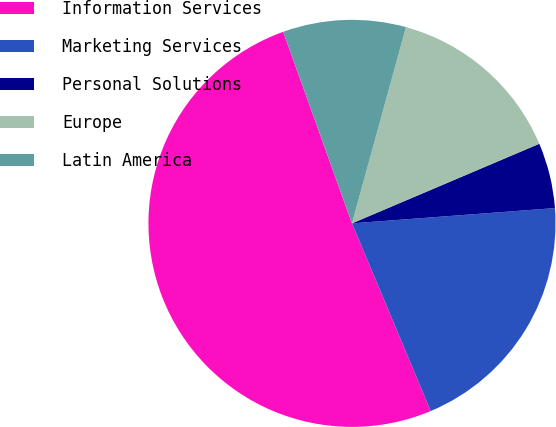<chart> <loc_0><loc_0><loc_500><loc_500><pie_chart><fcel>Information Services<fcel>Marketing Services<fcel>Personal Solutions<fcel>Europe<fcel>Latin America<nl><fcel>50.84%<fcel>19.87%<fcel>5.2%<fcel>14.33%<fcel>9.76%<nl></chart> 